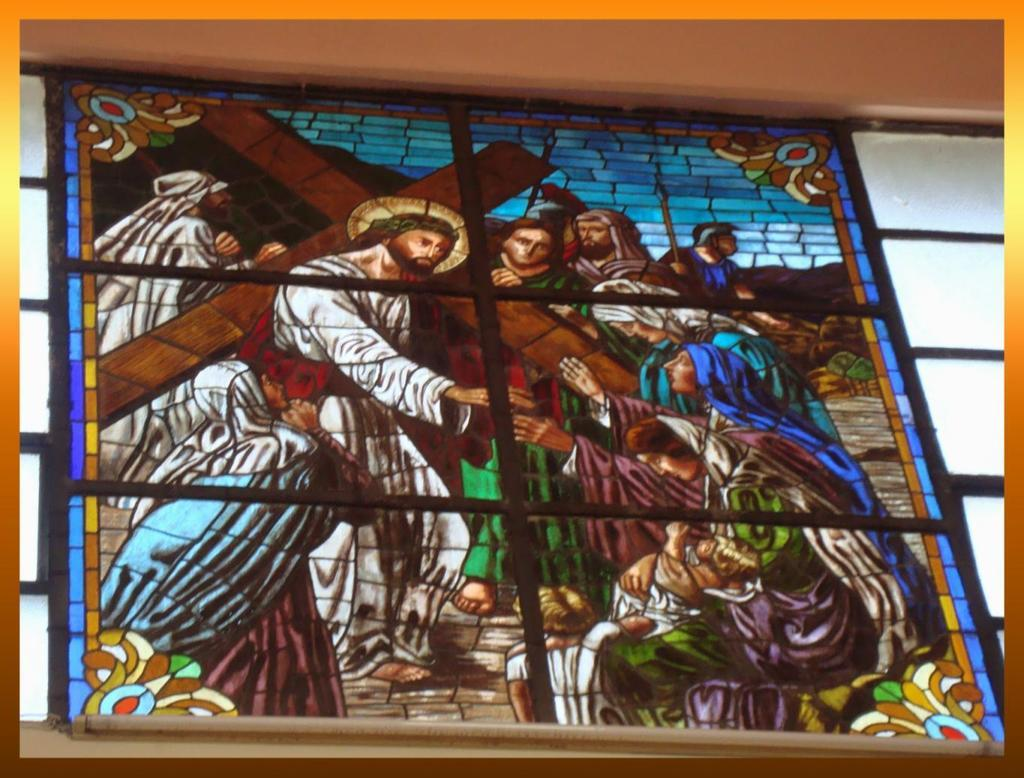What is on the wall in the image? There is a stained glass on the wall in the image. Is there any smoke coming from the stained glass in the image? There is no smoke present in the image; it only features a stained glass on the wall. 